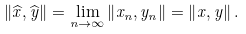<formula> <loc_0><loc_0><loc_500><loc_500>\left \| \widehat { x } , \widehat { y } \right \| = \lim _ { n \rightarrow \infty } \left \| x _ { n } , y _ { n } \right \| = \left \| x , y \right \| .</formula> 